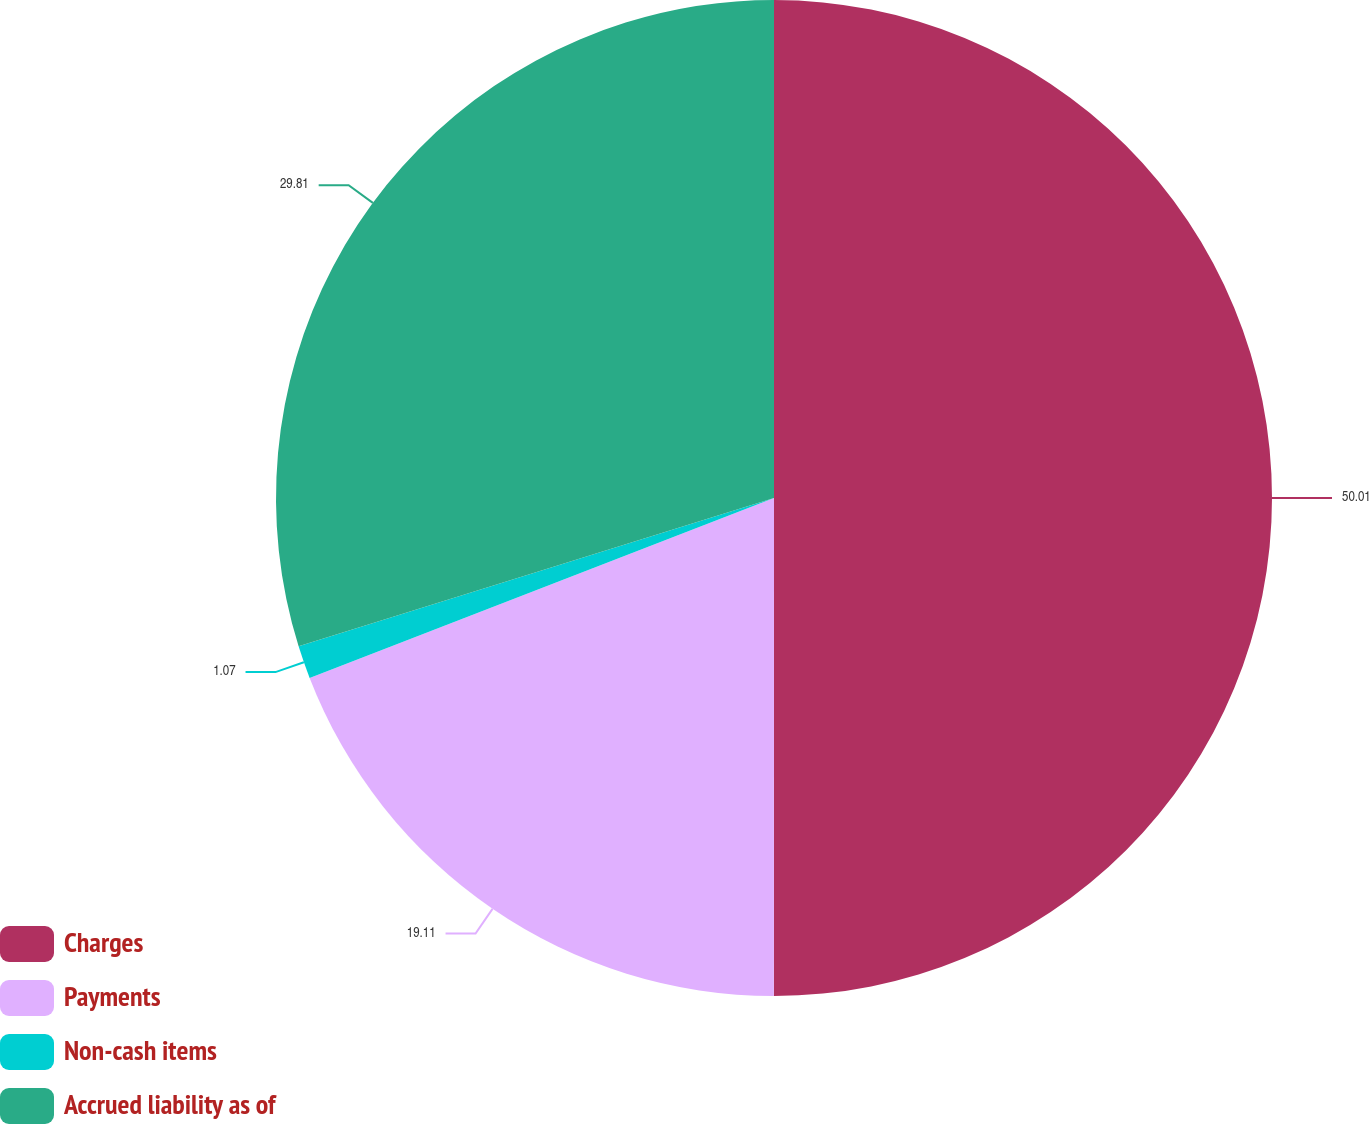Convert chart to OTSL. <chart><loc_0><loc_0><loc_500><loc_500><pie_chart><fcel>Charges<fcel>Payments<fcel>Non-cash items<fcel>Accrued liability as of<nl><fcel>50.0%<fcel>19.11%<fcel>1.07%<fcel>29.81%<nl></chart> 